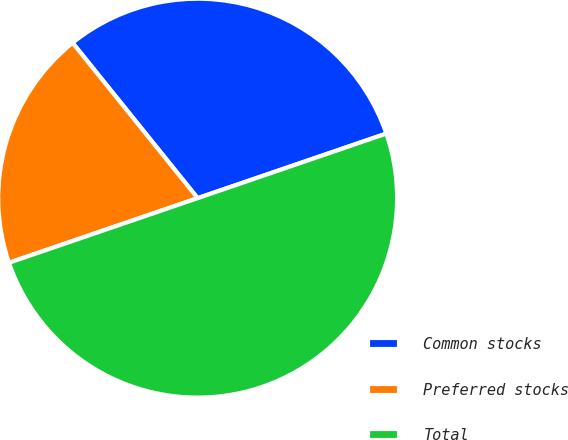Convert chart. <chart><loc_0><loc_0><loc_500><loc_500><pie_chart><fcel>Common stocks<fcel>Preferred stocks<fcel>Total<nl><fcel>30.54%<fcel>19.46%<fcel>50.0%<nl></chart> 